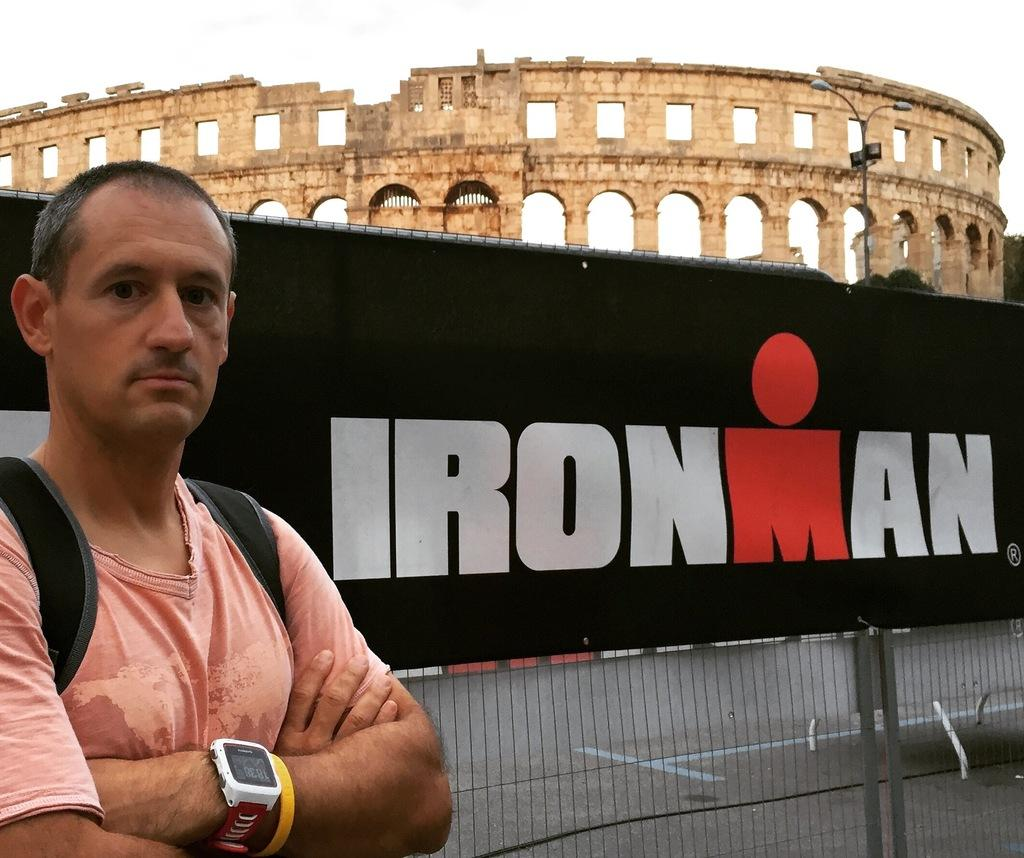<image>
Share a concise interpretation of the image provided. A man crosses his arms neck to an IronMan banner outside. 